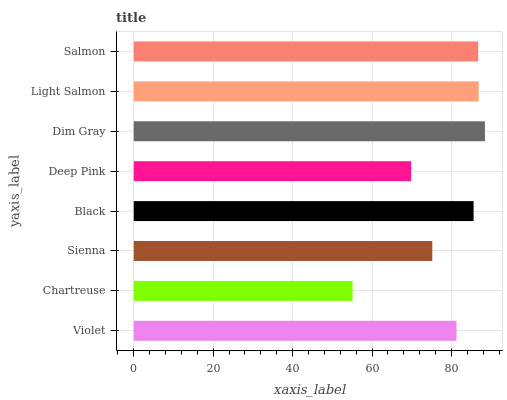Is Chartreuse the minimum?
Answer yes or no. Yes. Is Dim Gray the maximum?
Answer yes or no. Yes. Is Sienna the minimum?
Answer yes or no. No. Is Sienna the maximum?
Answer yes or no. No. Is Sienna greater than Chartreuse?
Answer yes or no. Yes. Is Chartreuse less than Sienna?
Answer yes or no. Yes. Is Chartreuse greater than Sienna?
Answer yes or no. No. Is Sienna less than Chartreuse?
Answer yes or no. No. Is Black the high median?
Answer yes or no. Yes. Is Violet the low median?
Answer yes or no. Yes. Is Sienna the high median?
Answer yes or no. No. Is Chartreuse the low median?
Answer yes or no. No. 